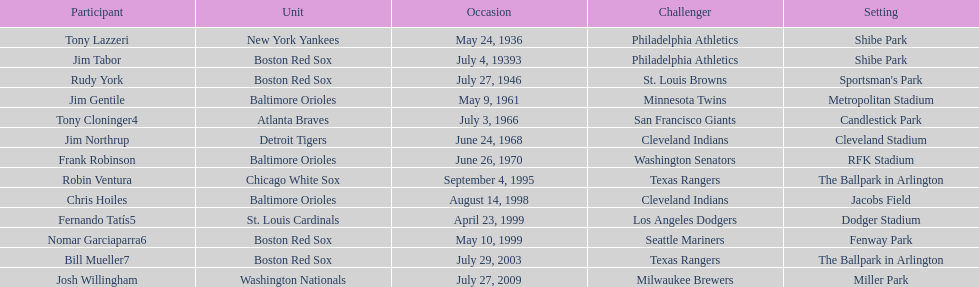Who was the opponent for the boston red sox on july 27, 1946? St. Louis Browns. 